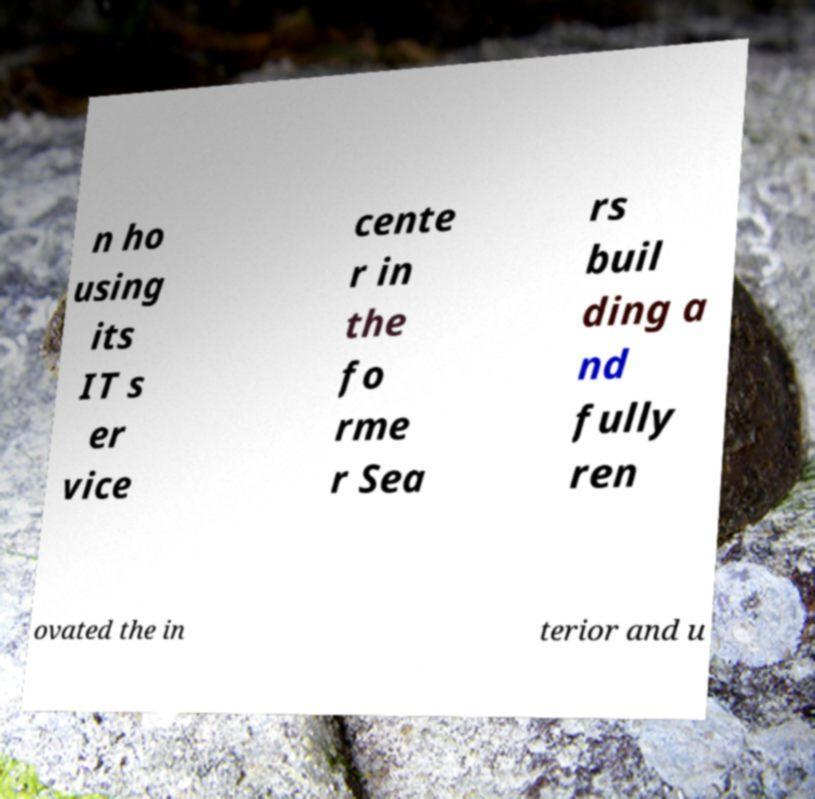Could you extract and type out the text from this image? n ho using its IT s er vice cente r in the fo rme r Sea rs buil ding a nd fully ren ovated the in terior and u 